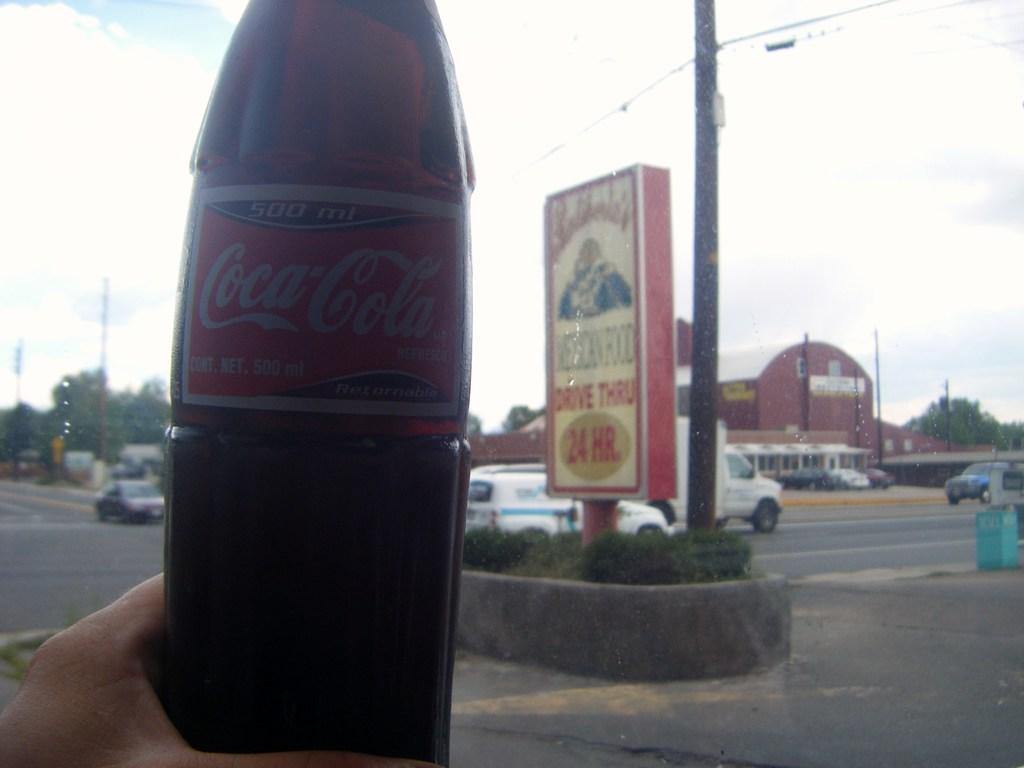<image>
Write a terse but informative summary of the picture. someone holding up a coca-cola bottle outside of a drive thru 